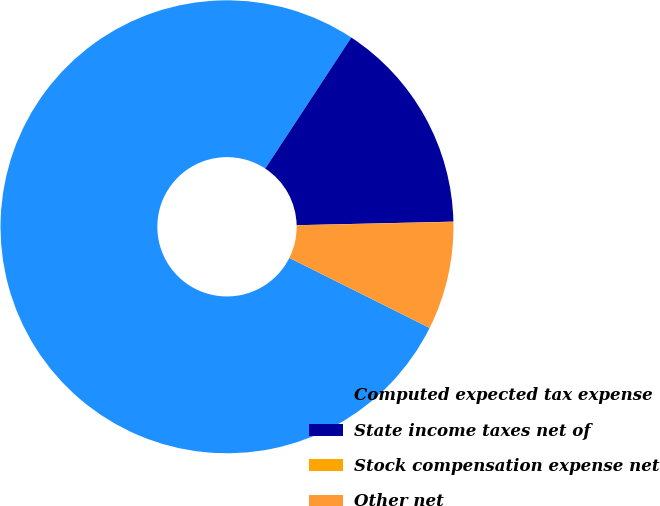<chart> <loc_0><loc_0><loc_500><loc_500><pie_chart><fcel>Computed expected tax expense<fcel>State income taxes net of<fcel>Stock compensation expense net<fcel>Other net<nl><fcel>76.88%<fcel>15.39%<fcel>0.02%<fcel>7.71%<nl></chart> 